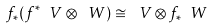<formula> <loc_0><loc_0><loc_500><loc_500>f _ { * } ( f ^ { * } \ V \otimes \ W ) \cong \ V \otimes f _ { * } \ W</formula> 